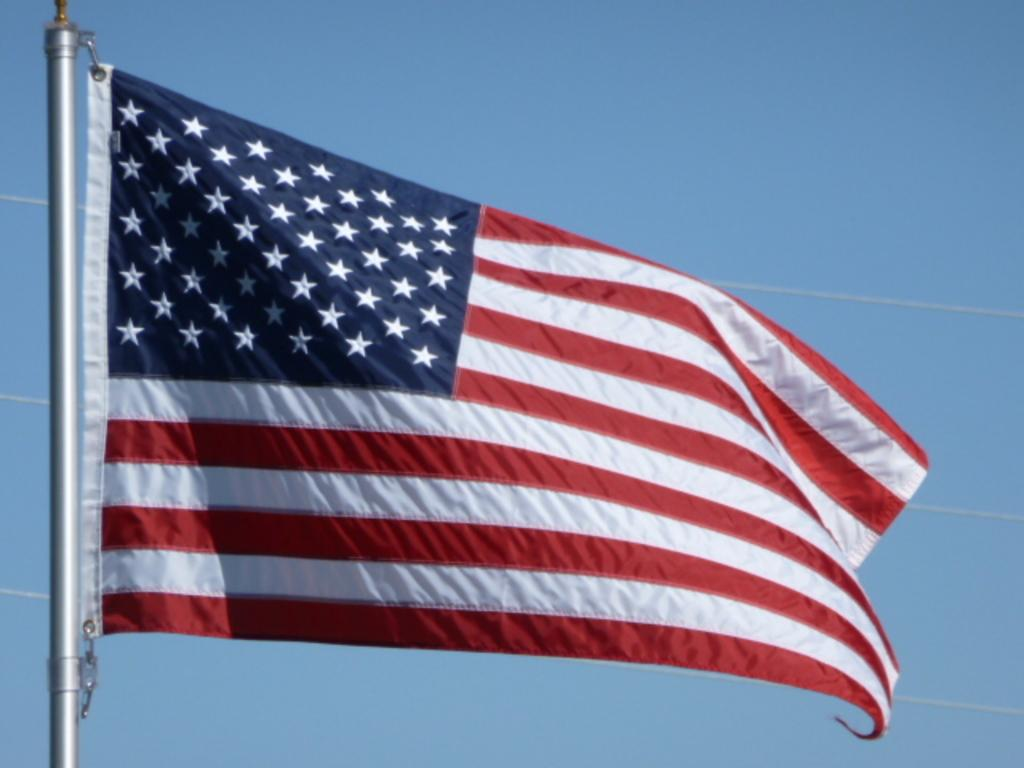What is the main subject in the center of the image? There is a flag present in the center of the image. What can be seen in the background of the image? There is a sky visible in the background of the image. What type of throne is depicted in the image? There is no throne present in the image; it features a flag in the center and a sky in the background. What shape is the roll in the image? There is no roll present in the image. 